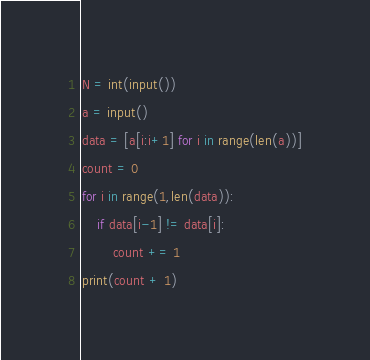<code> <loc_0><loc_0><loc_500><loc_500><_Python_>N = int(input())
a = input()
data = [a[i:i+1] for i in range(len(a))]
count = 0
for i in range(1,len(data)):
    if data[i-1] != data[i]:
        count += 1
print(count + 1)</code> 